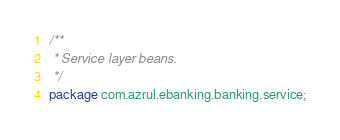Convert code to text. <code><loc_0><loc_0><loc_500><loc_500><_Java_>/**
 * Service layer beans.
 */
package com.azrul.ebanking.banking.service;
</code> 